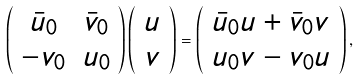Convert formula to latex. <formula><loc_0><loc_0><loc_500><loc_500>\left ( \begin{array} { c c } \bar { u } _ { 0 } & \bar { v } _ { 0 } \\ - v _ { 0 } & u _ { 0 } \end{array} \right ) \left ( \begin{array} { c } u \\ v \end{array} \right ) = \left ( \begin{array} { c } \bar { u } _ { 0 } u + \bar { v } _ { 0 } v \\ u _ { 0 } v - v _ { 0 } u \end{array} \right ) ,</formula> 